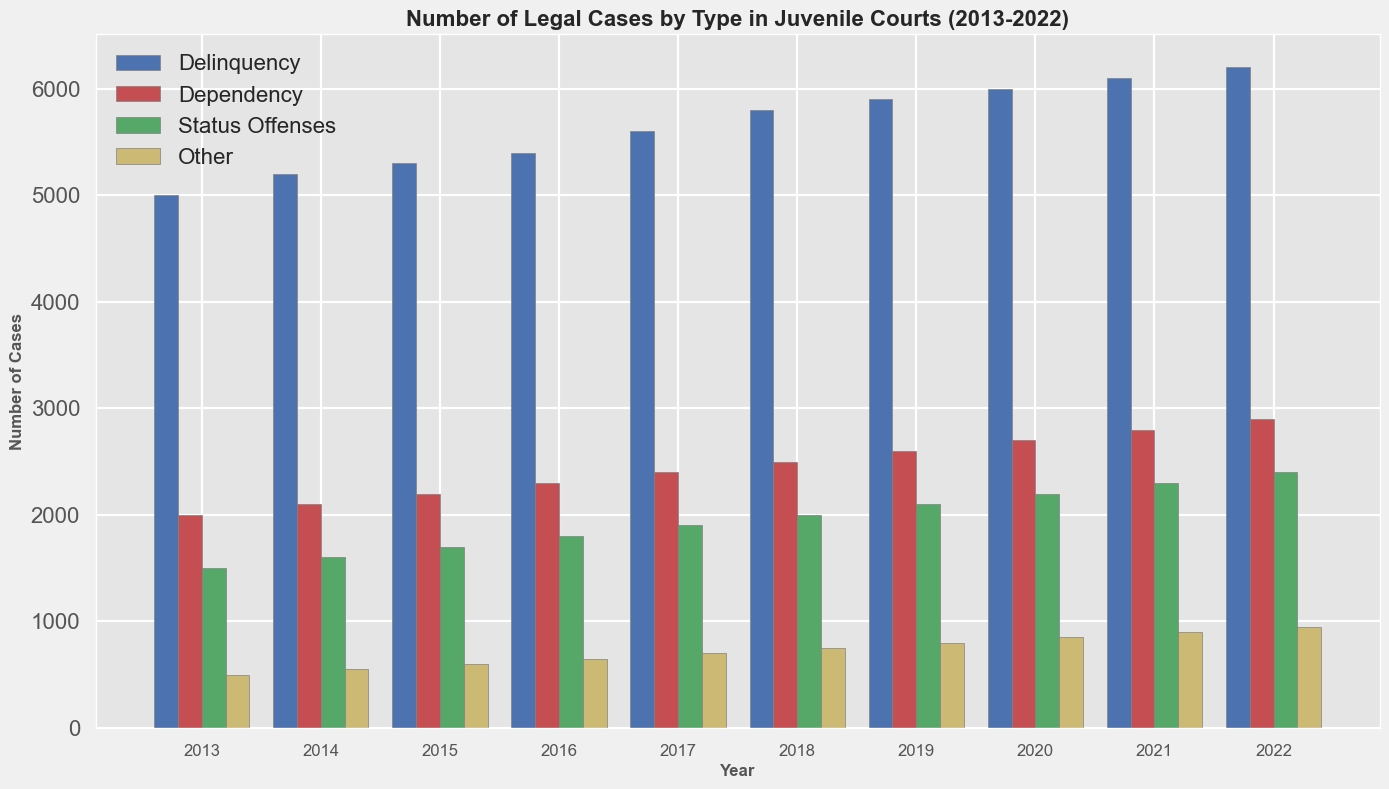What type of case had the highest number in 2017? The highest number in 2017 is represented by the tallest bar. In 2017, the tallest bar is blue, representing Delinquency cases.
Answer: Delinquency How many Dependency cases were there in 2020 compared to 2022? Looking at the red bars for 2020 and 2022, the Dependency cases in 2020 are 2700 and in 2022 are 2900. The difference is 2900 - 2700 = 200.
Answer: 200 more in 2022 What is the total number of Status Offenses and Other cases in 2016? Summing the green and yellow bars for 2016, Status Offenses = 1800 and Other = 650. The total is 1800 + 650 = 2450.
Answer: 2450 Which year had the lowest number of Dependency cases? The shortest red bar represents the lowest number of Dependency cases. The shortest bar is in 2013 with 2000 cases.
Answer: 2013 What is the average number of Delinquency cases from 2013 to 2022? Summing Delinquency cases over all years: 5000 + 5200 + 5300 + 5400 + 5600 + 5800 + 5900 + 6000 + 6100 + 6200 = 56500. Dividing by the number of years (10): 56500 / 10 = 5650.
Answer: 5650 What is the trend in the number of Delinquency cases from 2013 to 2022? Observing the blue bars from left to right, they increase steadily each year from 5000 in 2013 to 6200 in 2022.
Answer: Increasing What is the combined total of Dependency and Other types of cases in 2021? Summing the red and yellow bars for 2021, Dependency = 2800 and Other = 900. The total is 2800 + 900 = 3700.
Answer: 3700 In which year did Status Offenses exceed 2000 cases? The green bar representing Status Offenses exceeds 2000 first in 2019 with 2100 cases.
Answer: 2019 Which case type shows the slowest growth over the decade? By observing all the bar lengths, the yellow bars (Other) grow the least, from 500 in 2013 to 950 in 2022, increasing only by 450.
Answer: Other How do the numbers of Dependency cases compare to the numbers of Status Offenses in 2018? The red bar (Dependency) for 2018 is 2500 and the green bar (Status Offenses) is 2000. So, Dependency is 500 more than Status Offenses.
Answer: Dependency is 500 more 